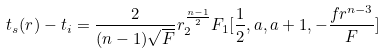<formula> <loc_0><loc_0><loc_500><loc_500>t _ { s } ( r ) - t _ { i } = \frac { 2 } { ( n - 1 ) \sqrt { F } } r ^ { \frac { n - 1 } { 2 } } _ { 2 } F _ { 1 } [ \frac { 1 } { 2 } , a , a + 1 , - \frac { f r ^ { n - 3 } } { F } ]</formula> 